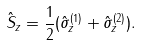<formula> <loc_0><loc_0><loc_500><loc_500>\hat { S } _ { z } = \frac { 1 } { 2 } ( \hat { \sigma } _ { z } ^ { ( 1 ) } + \hat { \sigma } _ { z } ^ { ( 2 ) } ) .</formula> 